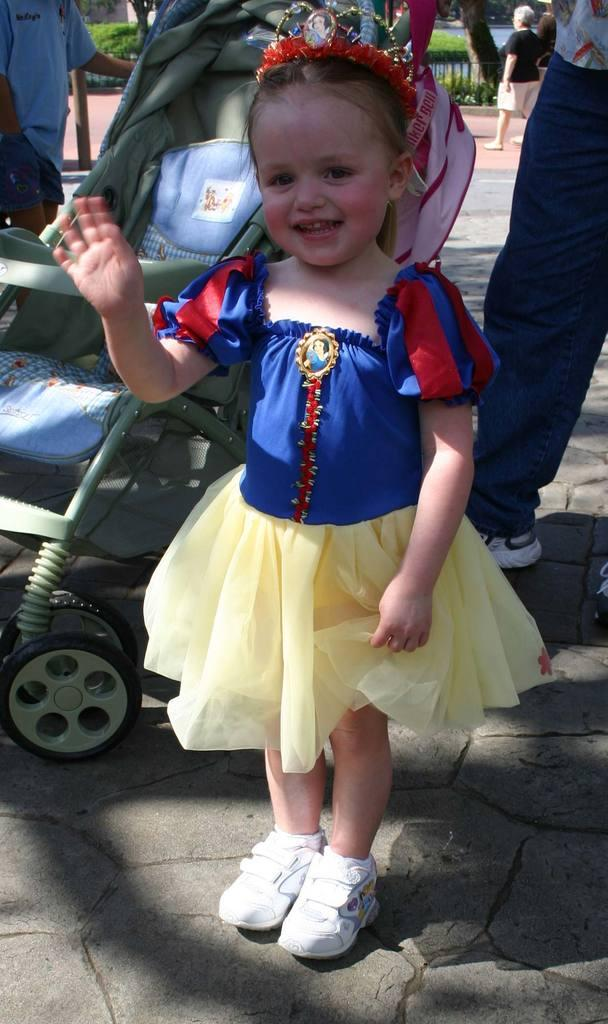Who can be seen in the image? There are people in the image, including a baby and a girl. What else is present in the image besides people? There are plants and branches in the image. What type of elbow is visible in the image? There is no elbow present in the image. Who is the father of the baby in the image? The provided facts do not mention a father or any familial relationships, so it cannot be determined from the image. 